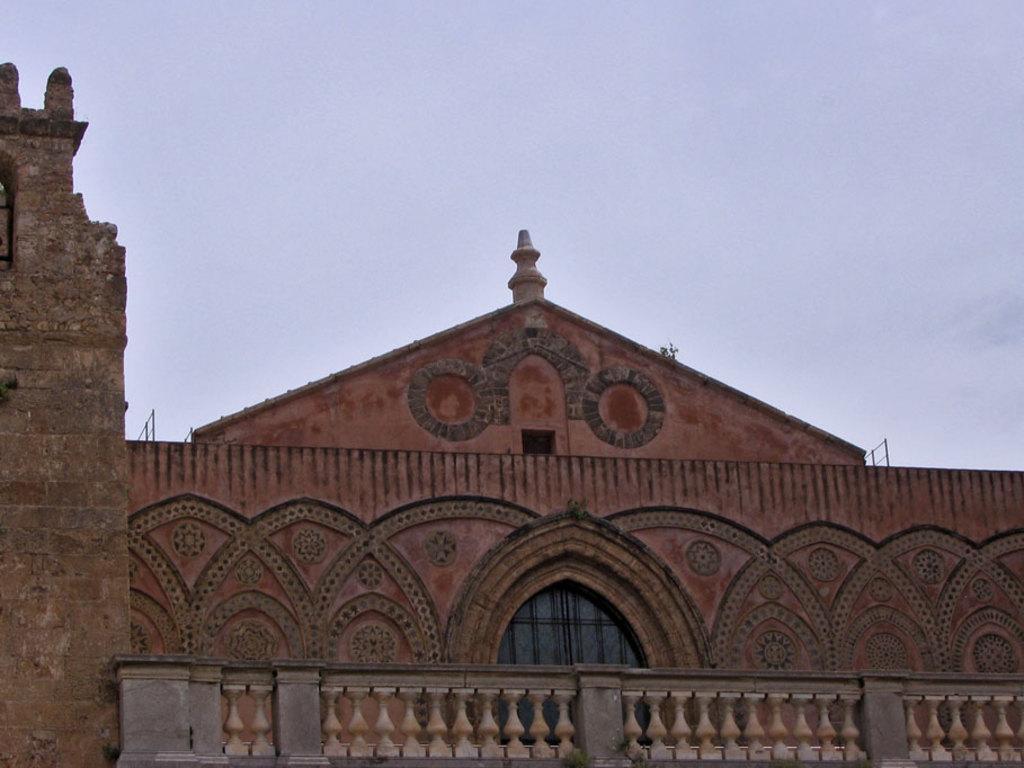Describe this image in one or two sentences. In this picture we can see a building with doors. At the bottom of the image, there is a baluster. At the top of the image, there is the sky. 